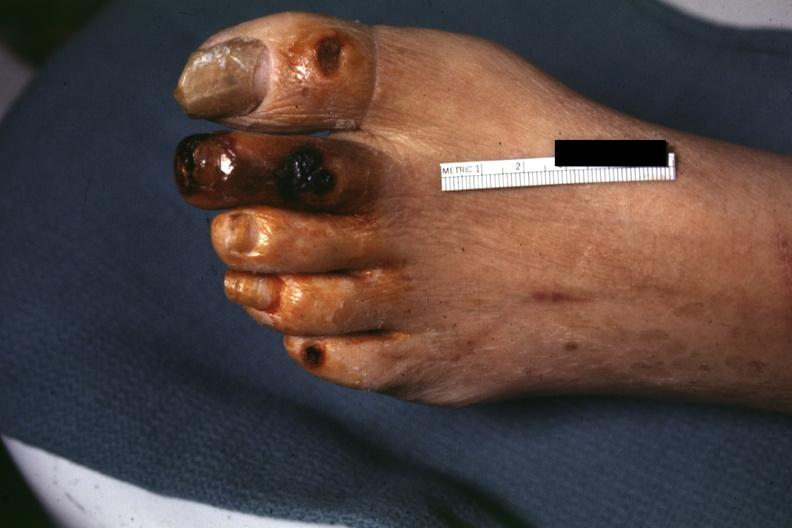does this image show good close-up of gangrene?
Answer the question using a single word or phrase. Yes 